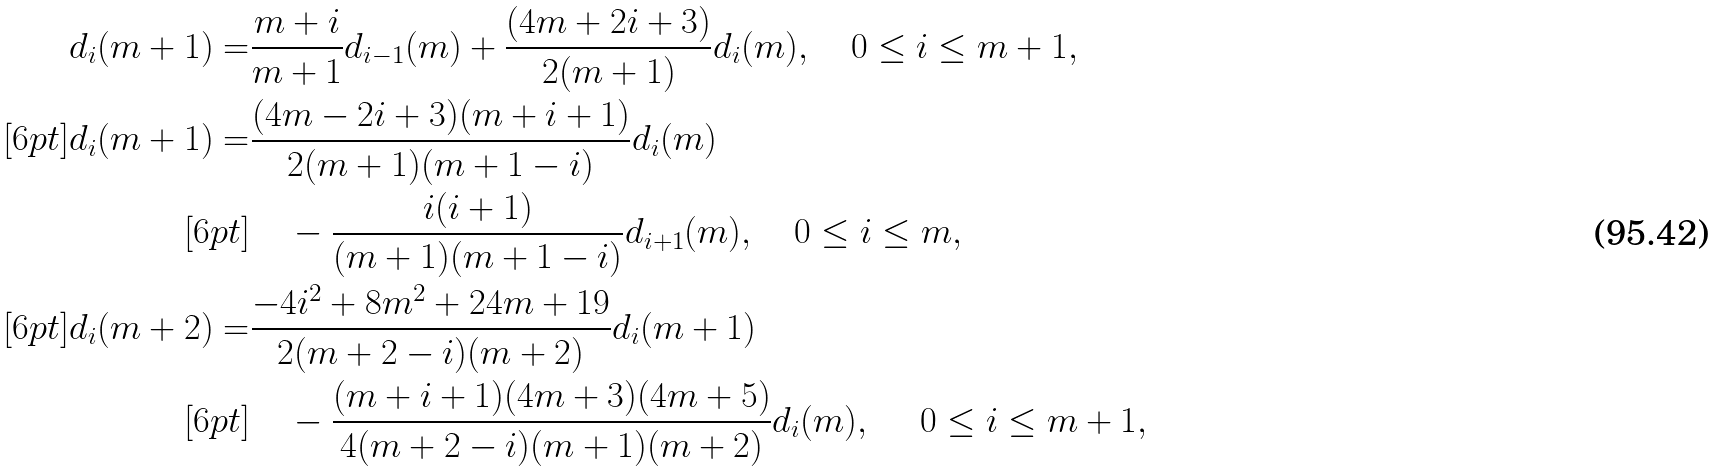<formula> <loc_0><loc_0><loc_500><loc_500>d _ { i } ( m + 1 ) = & \frac { m + i } { m + 1 } d _ { i - 1 } ( m ) + \frac { ( 4 m + 2 i + 3 ) } { 2 ( m + 1 ) } d _ { i } ( m ) , \quad 0 \leq i \leq m + 1 , \\ [ 6 p t ] d _ { i } ( m + 1 ) = & \frac { ( 4 m - 2 i + 3 ) ( m + i + 1 ) } { 2 ( m + 1 ) ( m + 1 - i ) } d _ { i } ( m ) \\ [ 6 p t ] & \quad - \frac { i ( i + 1 ) } { ( m + 1 ) ( m + 1 - i ) } d _ { i + 1 } ( m ) , \quad 0 \leq i \leq m , \\ [ 6 p t ] d _ { i } ( m + 2 ) = & \frac { - 4 i ^ { 2 } + 8 m ^ { 2 } + 2 4 m + 1 9 } { 2 ( m + 2 - i ) ( m + 2 ) } d _ { i } ( m + 1 ) \\ [ 6 p t ] & \quad - \frac { ( m + i + 1 ) ( 4 m + 3 ) ( 4 m + 5 ) } { 4 ( m + 2 - i ) ( m + 1 ) ( m + 2 ) } d _ { i } ( m ) , \quad \ 0 \leq i \leq m + 1 ,</formula> 